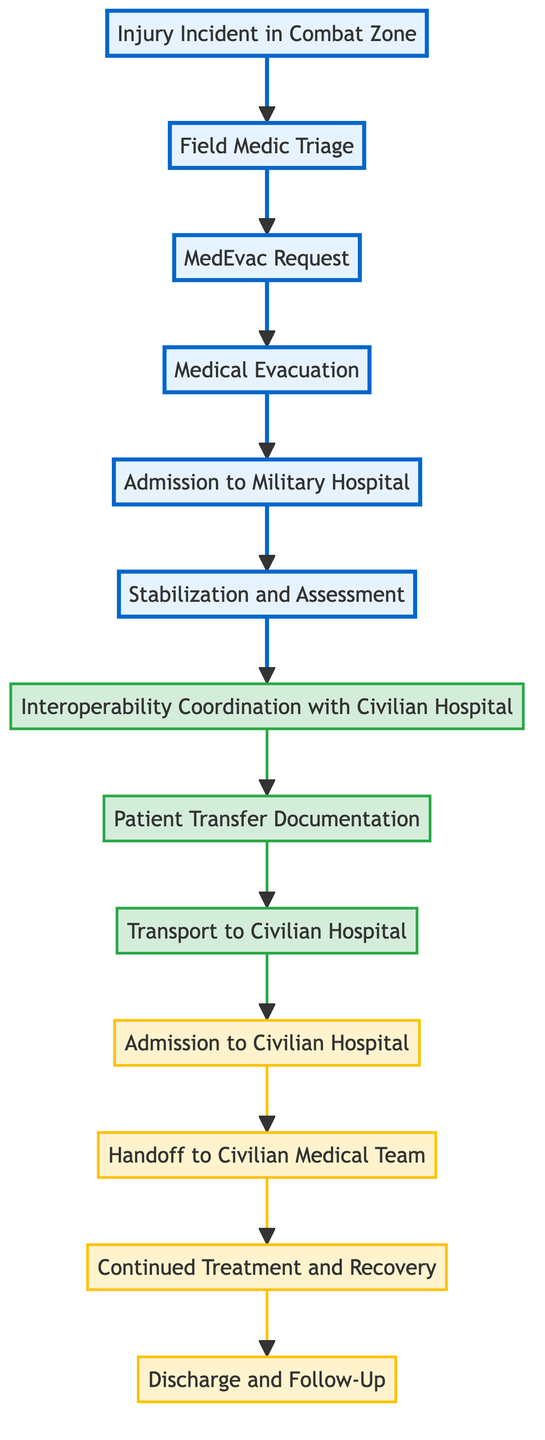What is the first node in the diagram? The first node in the flow chart is "Injury Incident in Combat Zone," indicating the starting point of the process.
Answer: Injury Incident in Combat Zone How many nodes are highlighted in the diagram? There are six highlighted nodes in the diagram, representing the military medical process stages before the interoperability coordination.
Answer: 6 What node connects "Stabilization and Assessment" to "Interoperability Coordination with Civilian Hospital"? The node connecting "Stabilization and Assessment" to "Interoperability Coordination with Civilian Hospital" is "Stabilization and Assessment." It indicates that after the patient's condition is stabilized, coordination occurs with civilian hospitals.
Answer: Stabilization and Assessment What is the final node in the flowchart? The final node in the flowchart is "Discharge and Follow-Up," which indicates the conclusion of the medical process with ongoing care plans.
Answer: Discharge and Follow-Up What is the link between "Patient Transfer Documentation" and "Transport to Civilian Hospital"? The link between "Patient Transfer Documentation" and "Transport to Civilian Hospital" indicates that transfer documentation must be prepared before transporting the patient to the civilian facility.
Answer: Documentation How many total nodes are depicted in the diagram? The diagram includes a total of twelve nodes that represent various stages in the interoperability flow between military medics and civilian medical facilities.
Answer: 12 What role does the "Handoff to Civilian Medical Team" play in the process? The "Handoff to Civilian Medical Team" is crucial as it represents the transfer of patient information from military to civilian caregivers, ensuring continuity of care.
Answer: Transfer of information Which two nodes represent the transition from military to civilian medical care? The two nodes representing the transition from military to civilian medical care are "Transport to Civilian Hospital" and "Admission to Civilian Hospital." They illustrate the movement of the patient to civilian healthcare.
Answer: Transport to Civilian Hospital and Admission to Civilian Hospital What is the purpose of "Interoperability Coordination with Civilian Hospital"? The purpose of "Interoperability Coordination with Civilian Hospital" is to ensure that the military hospital collaborates with civilian facilities for comprehensive patient care, especially for specialized needs.
Answer: Collaboration 